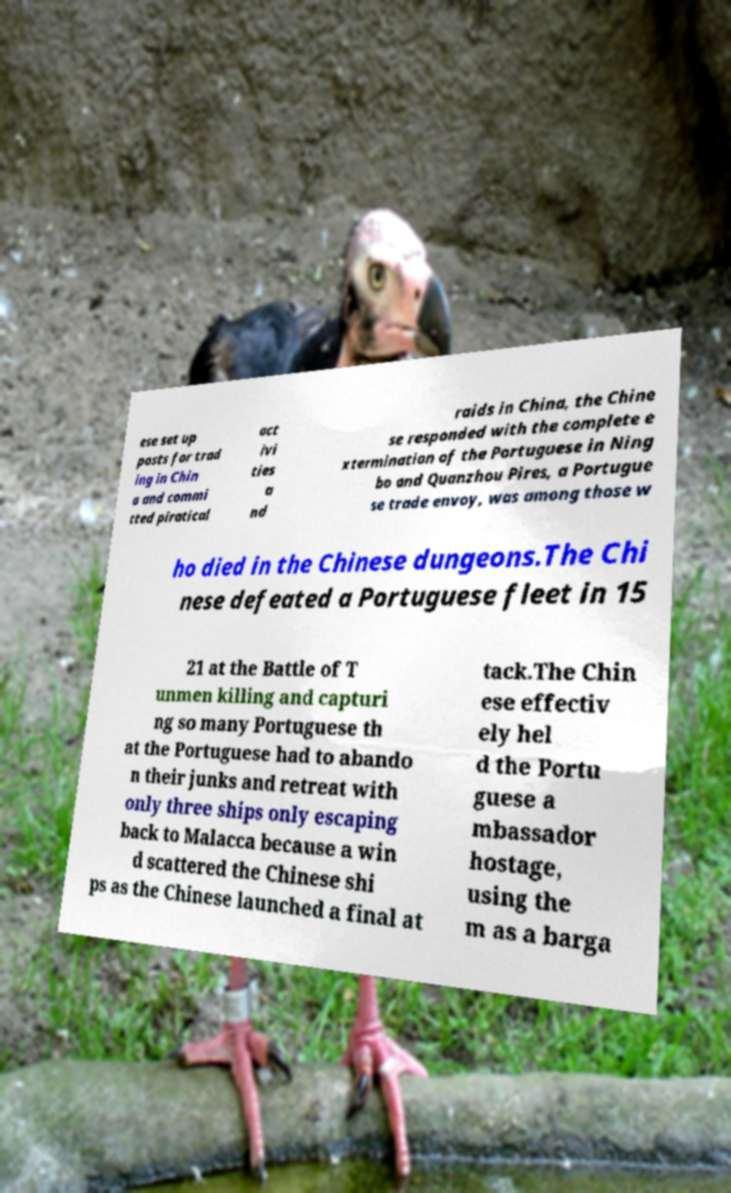I need the written content from this picture converted into text. Can you do that? ese set up posts for trad ing in Chin a and commi tted piratical act ivi ties a nd raids in China, the Chine se responded with the complete e xtermination of the Portuguese in Ning bo and Quanzhou Pires, a Portugue se trade envoy, was among those w ho died in the Chinese dungeons.The Chi nese defeated a Portuguese fleet in 15 21 at the Battle of T unmen killing and capturi ng so many Portuguese th at the Portuguese had to abando n their junks and retreat with only three ships only escaping back to Malacca because a win d scattered the Chinese shi ps as the Chinese launched a final at tack.The Chin ese effectiv ely hel d the Portu guese a mbassador hostage, using the m as a barga 